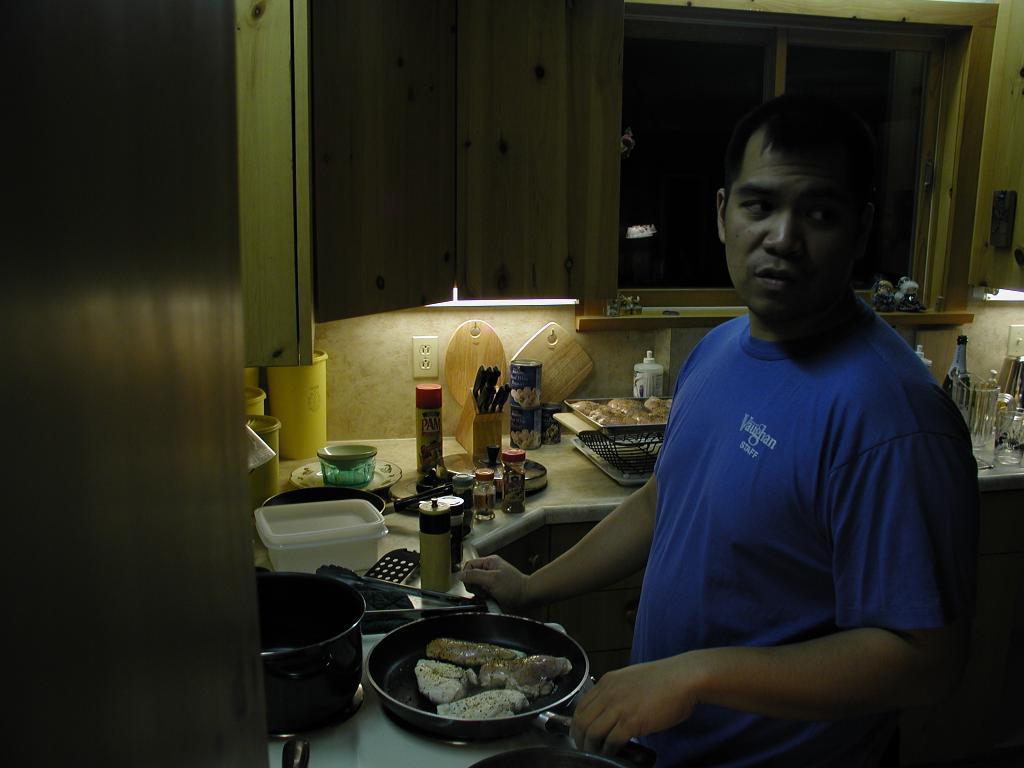How would you summarize this image in a sentence or two? In the foreground, I can see a person is standing on the floor is holding a pan in hand, in which I can see food items. In the background, I can see a cabinet on which jars, bottles, trays, kitchen tools, some objects are kept, cupboard, shelves and a wall. This image taken, maybe in a room. 